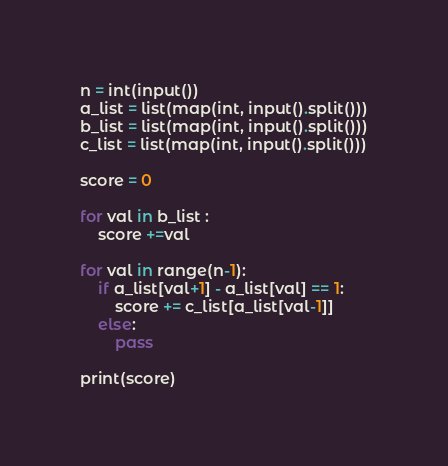<code> <loc_0><loc_0><loc_500><loc_500><_Python_>n = int(input())
a_list = list(map(int, input().split()))
b_list = list(map(int, input().split()))
c_list = list(map(int, input().split()))

score = 0

for val in b_list :
	score +=val
	
for val in range(n-1):
	if a_list[val+1] - a_list[val] == 1:
		score += c_list[a_list[val-1]]
	else:
		pass

print(score)</code> 